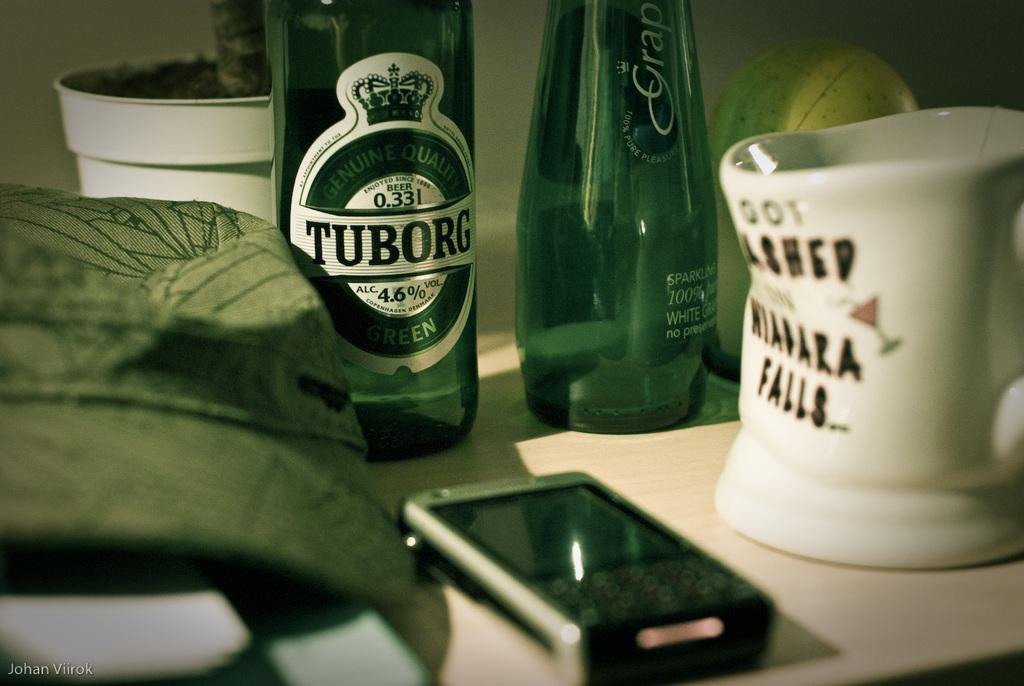<image>
Relay a brief, clear account of the picture shown. An empty green bottle of Tuborg is on the table with another bottle and a mug. 